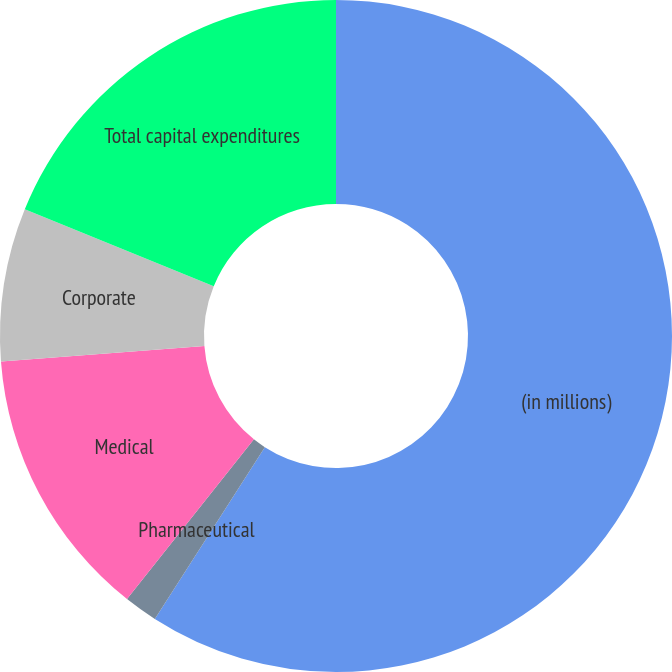Convert chart. <chart><loc_0><loc_0><loc_500><loc_500><pie_chart><fcel>(in millions)<fcel>Pharmaceutical<fcel>Medical<fcel>Corporate<fcel>Total capital expenditures<nl><fcel>59.07%<fcel>1.62%<fcel>13.11%<fcel>7.36%<fcel>18.85%<nl></chart> 